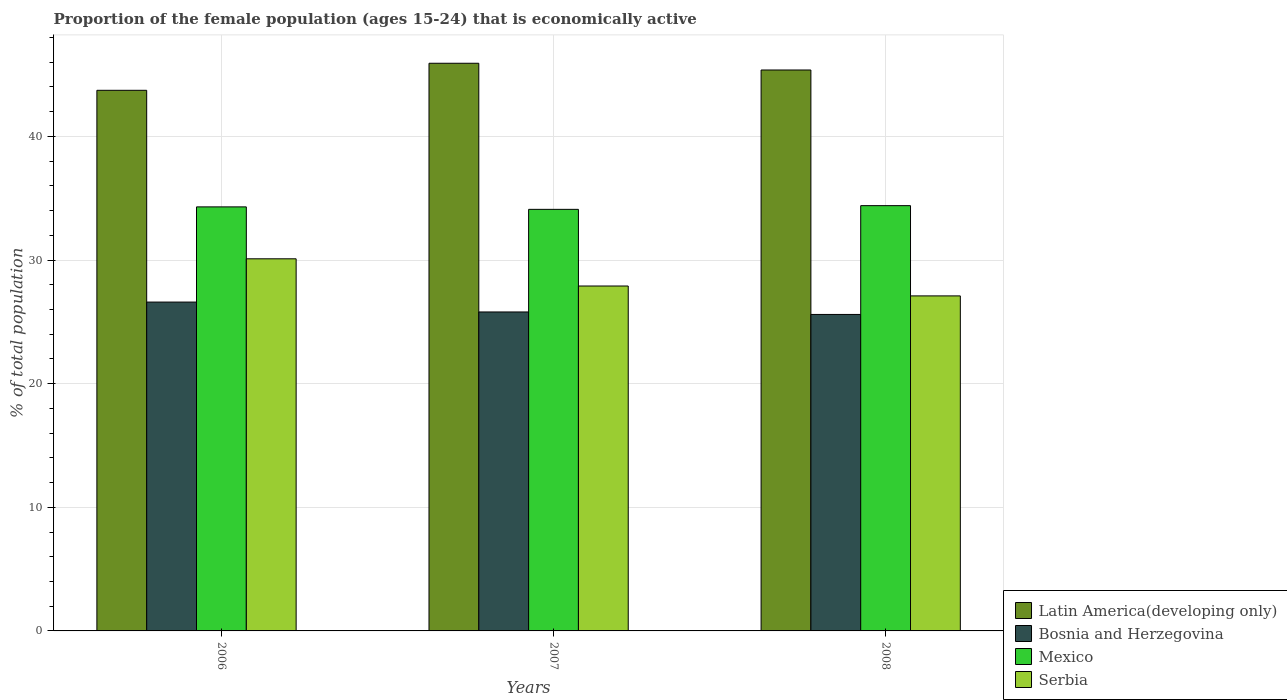How many different coloured bars are there?
Make the answer very short. 4. How many groups of bars are there?
Offer a terse response. 3. Are the number of bars per tick equal to the number of legend labels?
Give a very brief answer. Yes. What is the label of the 3rd group of bars from the left?
Offer a terse response. 2008. In how many cases, is the number of bars for a given year not equal to the number of legend labels?
Your answer should be compact. 0. What is the proportion of the female population that is economically active in Latin America(developing only) in 2006?
Provide a succinct answer. 43.73. Across all years, what is the maximum proportion of the female population that is economically active in Latin America(developing only)?
Give a very brief answer. 45.92. Across all years, what is the minimum proportion of the female population that is economically active in Mexico?
Keep it short and to the point. 34.1. In which year was the proportion of the female population that is economically active in Bosnia and Herzegovina maximum?
Keep it short and to the point. 2006. What is the total proportion of the female population that is economically active in Latin America(developing only) in the graph?
Give a very brief answer. 135.02. What is the difference between the proportion of the female population that is economically active in Serbia in 2007 and that in 2008?
Provide a succinct answer. 0.8. What is the difference between the proportion of the female population that is economically active in Mexico in 2008 and the proportion of the female population that is economically active in Serbia in 2006?
Make the answer very short. 4.3. What is the average proportion of the female population that is economically active in Serbia per year?
Your answer should be compact. 28.37. In the year 2007, what is the difference between the proportion of the female population that is economically active in Serbia and proportion of the female population that is economically active in Latin America(developing only)?
Your answer should be very brief. -18.02. What is the ratio of the proportion of the female population that is economically active in Serbia in 2006 to that in 2008?
Ensure brevity in your answer.  1.11. Is the proportion of the female population that is economically active in Bosnia and Herzegovina in 2006 less than that in 2007?
Provide a succinct answer. No. Is the difference between the proportion of the female population that is economically active in Serbia in 2007 and 2008 greater than the difference between the proportion of the female population that is economically active in Latin America(developing only) in 2007 and 2008?
Your answer should be very brief. Yes. What is the difference between the highest and the second highest proportion of the female population that is economically active in Mexico?
Provide a short and direct response. 0.1. What is the difference between the highest and the lowest proportion of the female population that is economically active in Mexico?
Your answer should be very brief. 0.3. In how many years, is the proportion of the female population that is economically active in Serbia greater than the average proportion of the female population that is economically active in Serbia taken over all years?
Make the answer very short. 1. Is it the case that in every year, the sum of the proportion of the female population that is economically active in Serbia and proportion of the female population that is economically active in Mexico is greater than the sum of proportion of the female population that is economically active in Latin America(developing only) and proportion of the female population that is economically active in Bosnia and Herzegovina?
Give a very brief answer. No. What does the 4th bar from the right in 2007 represents?
Provide a succinct answer. Latin America(developing only). Is it the case that in every year, the sum of the proportion of the female population that is economically active in Mexico and proportion of the female population that is economically active in Serbia is greater than the proportion of the female population that is economically active in Bosnia and Herzegovina?
Provide a short and direct response. Yes. How many bars are there?
Give a very brief answer. 12. Does the graph contain grids?
Offer a terse response. Yes. What is the title of the graph?
Provide a succinct answer. Proportion of the female population (ages 15-24) that is economically active. Does "Guatemala" appear as one of the legend labels in the graph?
Provide a short and direct response. No. What is the label or title of the Y-axis?
Give a very brief answer. % of total population. What is the % of total population in Latin America(developing only) in 2006?
Make the answer very short. 43.73. What is the % of total population of Bosnia and Herzegovina in 2006?
Ensure brevity in your answer.  26.6. What is the % of total population of Mexico in 2006?
Offer a terse response. 34.3. What is the % of total population in Serbia in 2006?
Ensure brevity in your answer.  30.1. What is the % of total population of Latin America(developing only) in 2007?
Keep it short and to the point. 45.92. What is the % of total population of Bosnia and Herzegovina in 2007?
Make the answer very short. 25.8. What is the % of total population of Mexico in 2007?
Make the answer very short. 34.1. What is the % of total population of Serbia in 2007?
Ensure brevity in your answer.  27.9. What is the % of total population in Latin America(developing only) in 2008?
Keep it short and to the point. 45.37. What is the % of total population in Bosnia and Herzegovina in 2008?
Your response must be concise. 25.6. What is the % of total population of Mexico in 2008?
Your answer should be compact. 34.4. What is the % of total population of Serbia in 2008?
Provide a succinct answer. 27.1. Across all years, what is the maximum % of total population of Latin America(developing only)?
Ensure brevity in your answer.  45.92. Across all years, what is the maximum % of total population of Bosnia and Herzegovina?
Your answer should be very brief. 26.6. Across all years, what is the maximum % of total population in Mexico?
Give a very brief answer. 34.4. Across all years, what is the maximum % of total population in Serbia?
Your response must be concise. 30.1. Across all years, what is the minimum % of total population in Latin America(developing only)?
Make the answer very short. 43.73. Across all years, what is the minimum % of total population of Bosnia and Herzegovina?
Provide a succinct answer. 25.6. Across all years, what is the minimum % of total population of Mexico?
Make the answer very short. 34.1. Across all years, what is the minimum % of total population of Serbia?
Provide a succinct answer. 27.1. What is the total % of total population of Latin America(developing only) in the graph?
Your answer should be compact. 135.02. What is the total % of total population of Bosnia and Herzegovina in the graph?
Provide a short and direct response. 78. What is the total % of total population of Mexico in the graph?
Offer a terse response. 102.8. What is the total % of total population of Serbia in the graph?
Your answer should be very brief. 85.1. What is the difference between the % of total population of Latin America(developing only) in 2006 and that in 2007?
Offer a terse response. -2.19. What is the difference between the % of total population of Latin America(developing only) in 2006 and that in 2008?
Offer a very short reply. -1.64. What is the difference between the % of total population of Bosnia and Herzegovina in 2006 and that in 2008?
Offer a terse response. 1. What is the difference between the % of total population in Mexico in 2006 and that in 2008?
Your answer should be compact. -0.1. What is the difference between the % of total population in Serbia in 2006 and that in 2008?
Your answer should be very brief. 3. What is the difference between the % of total population in Latin America(developing only) in 2007 and that in 2008?
Offer a very short reply. 0.55. What is the difference between the % of total population of Bosnia and Herzegovina in 2007 and that in 2008?
Your response must be concise. 0.2. What is the difference between the % of total population in Mexico in 2007 and that in 2008?
Make the answer very short. -0.3. What is the difference between the % of total population in Serbia in 2007 and that in 2008?
Make the answer very short. 0.8. What is the difference between the % of total population of Latin America(developing only) in 2006 and the % of total population of Bosnia and Herzegovina in 2007?
Provide a short and direct response. 17.93. What is the difference between the % of total population in Latin America(developing only) in 2006 and the % of total population in Mexico in 2007?
Offer a very short reply. 9.63. What is the difference between the % of total population of Latin America(developing only) in 2006 and the % of total population of Serbia in 2007?
Offer a very short reply. 15.83. What is the difference between the % of total population in Latin America(developing only) in 2006 and the % of total population in Bosnia and Herzegovina in 2008?
Your answer should be compact. 18.13. What is the difference between the % of total population in Latin America(developing only) in 2006 and the % of total population in Mexico in 2008?
Ensure brevity in your answer.  9.33. What is the difference between the % of total population of Latin America(developing only) in 2006 and the % of total population of Serbia in 2008?
Provide a succinct answer. 16.63. What is the difference between the % of total population of Bosnia and Herzegovina in 2006 and the % of total population of Mexico in 2008?
Keep it short and to the point. -7.8. What is the difference between the % of total population of Mexico in 2006 and the % of total population of Serbia in 2008?
Offer a terse response. 7.2. What is the difference between the % of total population of Latin America(developing only) in 2007 and the % of total population of Bosnia and Herzegovina in 2008?
Your answer should be compact. 20.32. What is the difference between the % of total population in Latin America(developing only) in 2007 and the % of total population in Mexico in 2008?
Your response must be concise. 11.52. What is the difference between the % of total population of Latin America(developing only) in 2007 and the % of total population of Serbia in 2008?
Keep it short and to the point. 18.82. What is the average % of total population in Latin America(developing only) per year?
Ensure brevity in your answer.  45.01. What is the average % of total population in Bosnia and Herzegovina per year?
Ensure brevity in your answer.  26. What is the average % of total population of Mexico per year?
Your response must be concise. 34.27. What is the average % of total population in Serbia per year?
Ensure brevity in your answer.  28.37. In the year 2006, what is the difference between the % of total population in Latin America(developing only) and % of total population in Bosnia and Herzegovina?
Your response must be concise. 17.13. In the year 2006, what is the difference between the % of total population of Latin America(developing only) and % of total population of Mexico?
Your answer should be compact. 9.43. In the year 2006, what is the difference between the % of total population in Latin America(developing only) and % of total population in Serbia?
Your answer should be compact. 13.63. In the year 2006, what is the difference between the % of total population in Bosnia and Herzegovina and % of total population in Serbia?
Ensure brevity in your answer.  -3.5. In the year 2007, what is the difference between the % of total population in Latin America(developing only) and % of total population in Bosnia and Herzegovina?
Your answer should be very brief. 20.12. In the year 2007, what is the difference between the % of total population in Latin America(developing only) and % of total population in Mexico?
Your response must be concise. 11.82. In the year 2007, what is the difference between the % of total population in Latin America(developing only) and % of total population in Serbia?
Give a very brief answer. 18.02. In the year 2007, what is the difference between the % of total population of Bosnia and Herzegovina and % of total population of Mexico?
Your answer should be very brief. -8.3. In the year 2007, what is the difference between the % of total population in Bosnia and Herzegovina and % of total population in Serbia?
Make the answer very short. -2.1. In the year 2007, what is the difference between the % of total population in Mexico and % of total population in Serbia?
Keep it short and to the point. 6.2. In the year 2008, what is the difference between the % of total population of Latin America(developing only) and % of total population of Bosnia and Herzegovina?
Your answer should be compact. 19.77. In the year 2008, what is the difference between the % of total population in Latin America(developing only) and % of total population in Mexico?
Provide a short and direct response. 10.97. In the year 2008, what is the difference between the % of total population of Latin America(developing only) and % of total population of Serbia?
Provide a short and direct response. 18.27. What is the ratio of the % of total population of Latin America(developing only) in 2006 to that in 2007?
Your response must be concise. 0.95. What is the ratio of the % of total population in Bosnia and Herzegovina in 2006 to that in 2007?
Your answer should be compact. 1.03. What is the ratio of the % of total population in Mexico in 2006 to that in 2007?
Your response must be concise. 1.01. What is the ratio of the % of total population of Serbia in 2006 to that in 2007?
Provide a succinct answer. 1.08. What is the ratio of the % of total population in Latin America(developing only) in 2006 to that in 2008?
Your answer should be very brief. 0.96. What is the ratio of the % of total population in Bosnia and Herzegovina in 2006 to that in 2008?
Offer a very short reply. 1.04. What is the ratio of the % of total population in Serbia in 2006 to that in 2008?
Offer a terse response. 1.11. What is the ratio of the % of total population in Latin America(developing only) in 2007 to that in 2008?
Give a very brief answer. 1.01. What is the ratio of the % of total population in Mexico in 2007 to that in 2008?
Keep it short and to the point. 0.99. What is the ratio of the % of total population in Serbia in 2007 to that in 2008?
Keep it short and to the point. 1.03. What is the difference between the highest and the second highest % of total population in Latin America(developing only)?
Ensure brevity in your answer.  0.55. What is the difference between the highest and the second highest % of total population of Bosnia and Herzegovina?
Your response must be concise. 0.8. What is the difference between the highest and the second highest % of total population in Mexico?
Offer a very short reply. 0.1. What is the difference between the highest and the second highest % of total population in Serbia?
Make the answer very short. 2.2. What is the difference between the highest and the lowest % of total population in Latin America(developing only)?
Your answer should be compact. 2.19. What is the difference between the highest and the lowest % of total population in Bosnia and Herzegovina?
Make the answer very short. 1. 